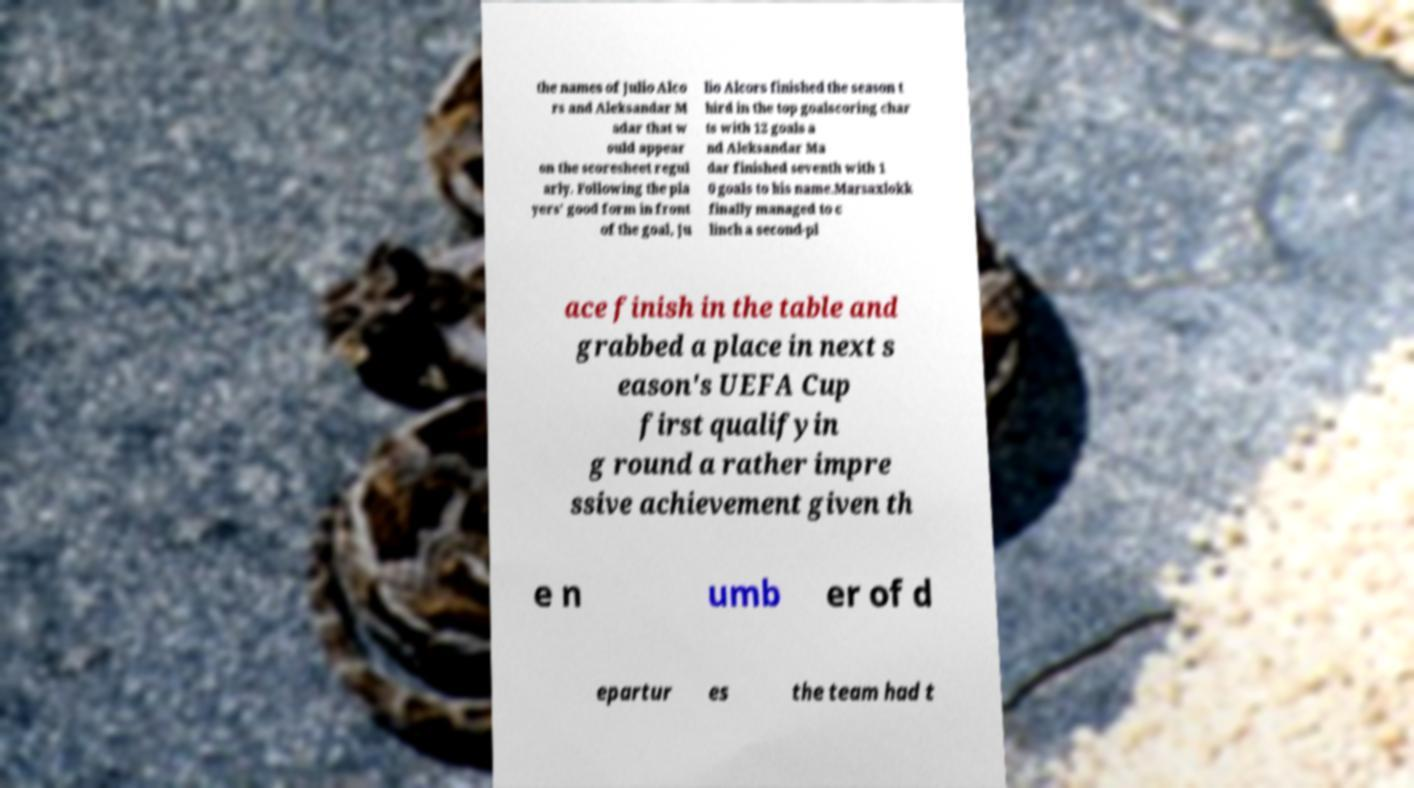Please read and relay the text visible in this image. What does it say? the names of Julio Alco rs and Aleksandar M adar that w ould appear on the scoresheet regul arly. Following the pla yers' good form in front of the goal, Ju lio Alcors finished the season t hird in the top goalscoring char ts with 12 goals a nd Aleksandar Ma dar finished seventh with 1 0 goals to his name.Marsaxlokk finally managed to c linch a second-pl ace finish in the table and grabbed a place in next s eason's UEFA Cup first qualifyin g round a rather impre ssive achievement given th e n umb er of d epartur es the team had t 